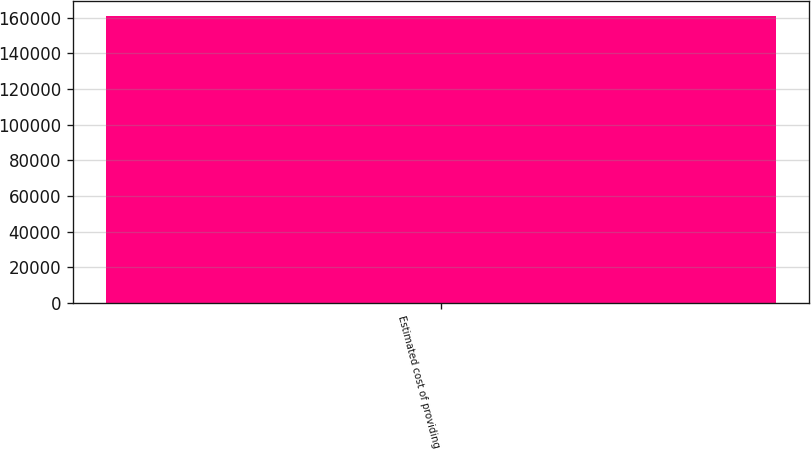Convert chart. <chart><loc_0><loc_0><loc_500><loc_500><bar_chart><fcel>Estimated cost of providing<nl><fcel>161013<nl></chart> 